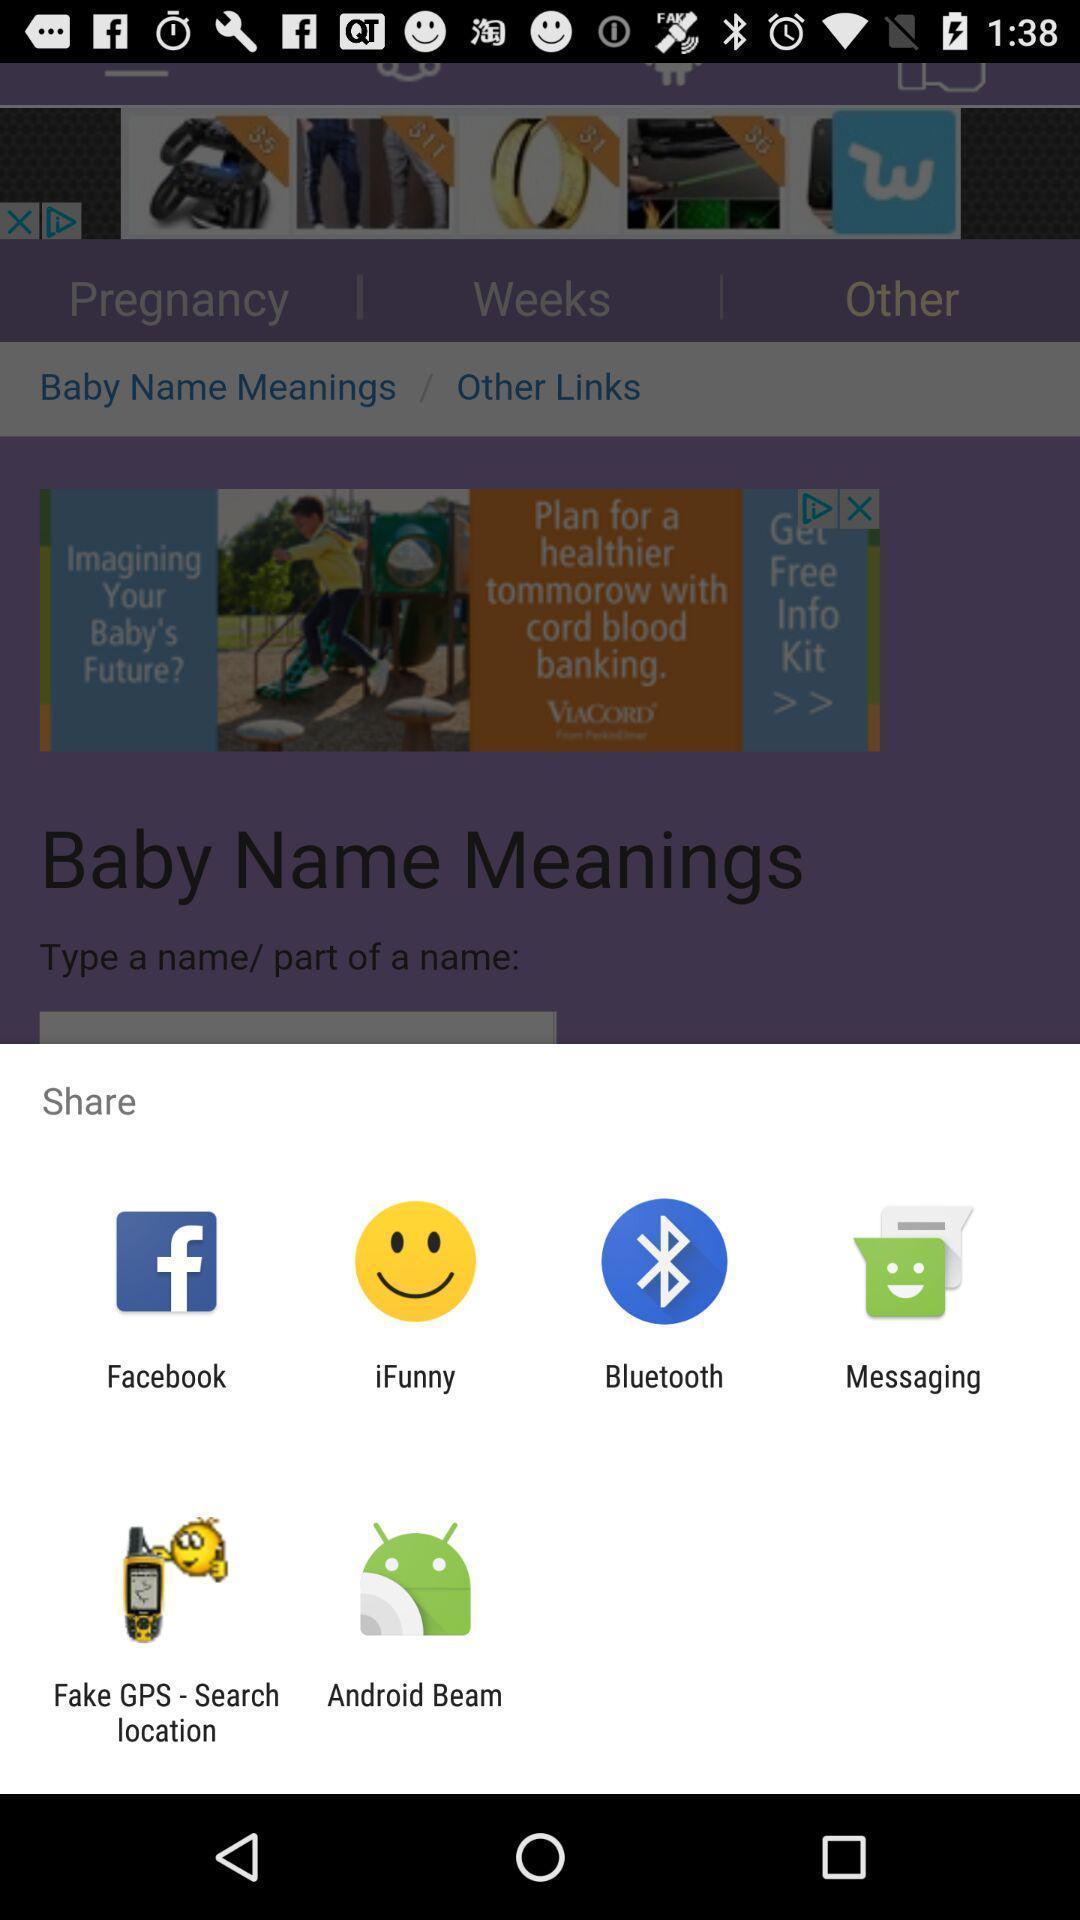Describe the content in this image. Share information with different apps. 